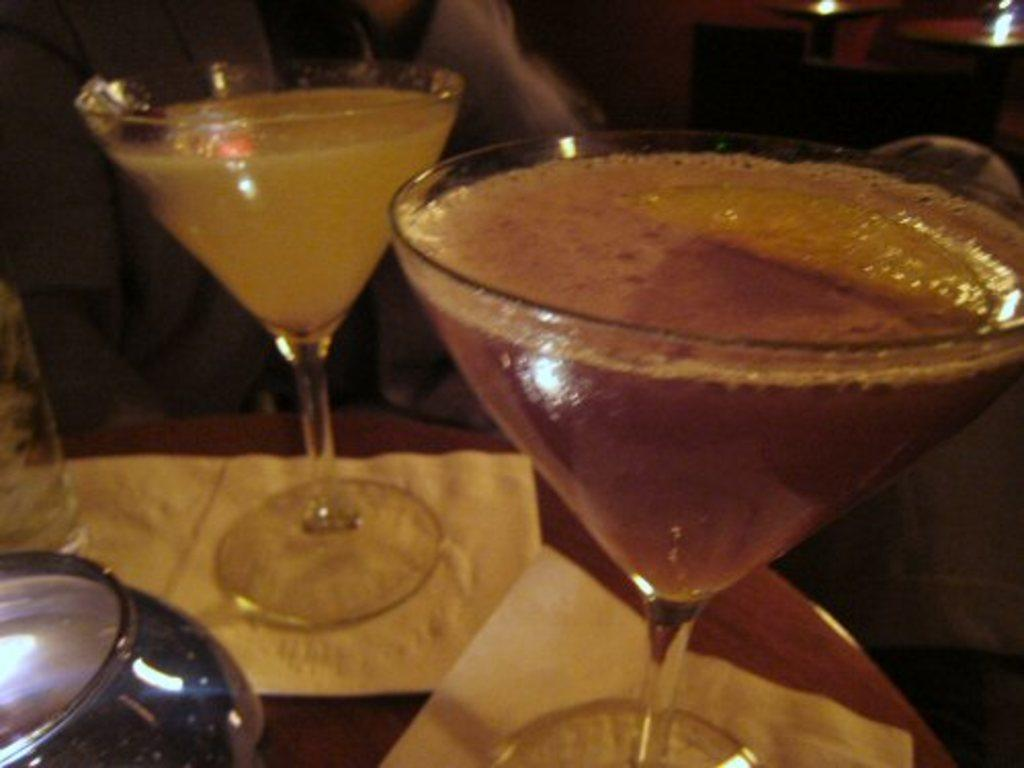What objects in the image contain liquid? There are two glasses containing some liquid in the image. What is the primary piece of furniture in the image? There is a table in the image. What is placed on the table? There is a paper on the table. How many bites can be seen in the image? There are no bites present in the image. What is the range of numbers visible on the paper in the image? There is no information about numbers on the paper in the image. 